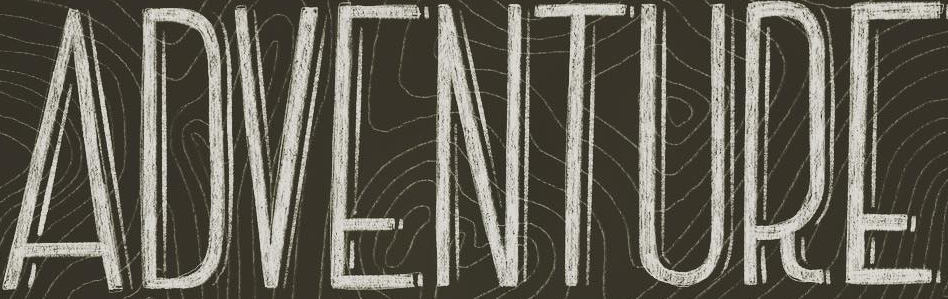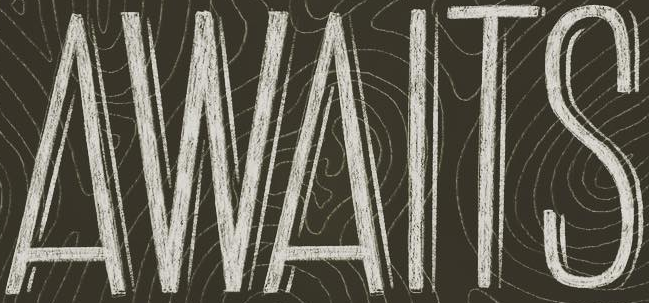What text appears in these images from left to right, separated by a semicolon? ADVENTURE; AWAITS 